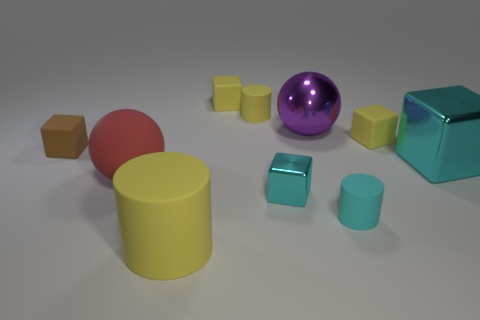Imagine these objects are part of a child's playset; how might they be used? In the context of a child's playset, each object might serve a different purpose. The spheres could represent balls for rolling and tossing, the cubes could be building blocks for construction play, and the cylinders could serve as pillars or to be stacked, promoting creativity and motor skill development. 